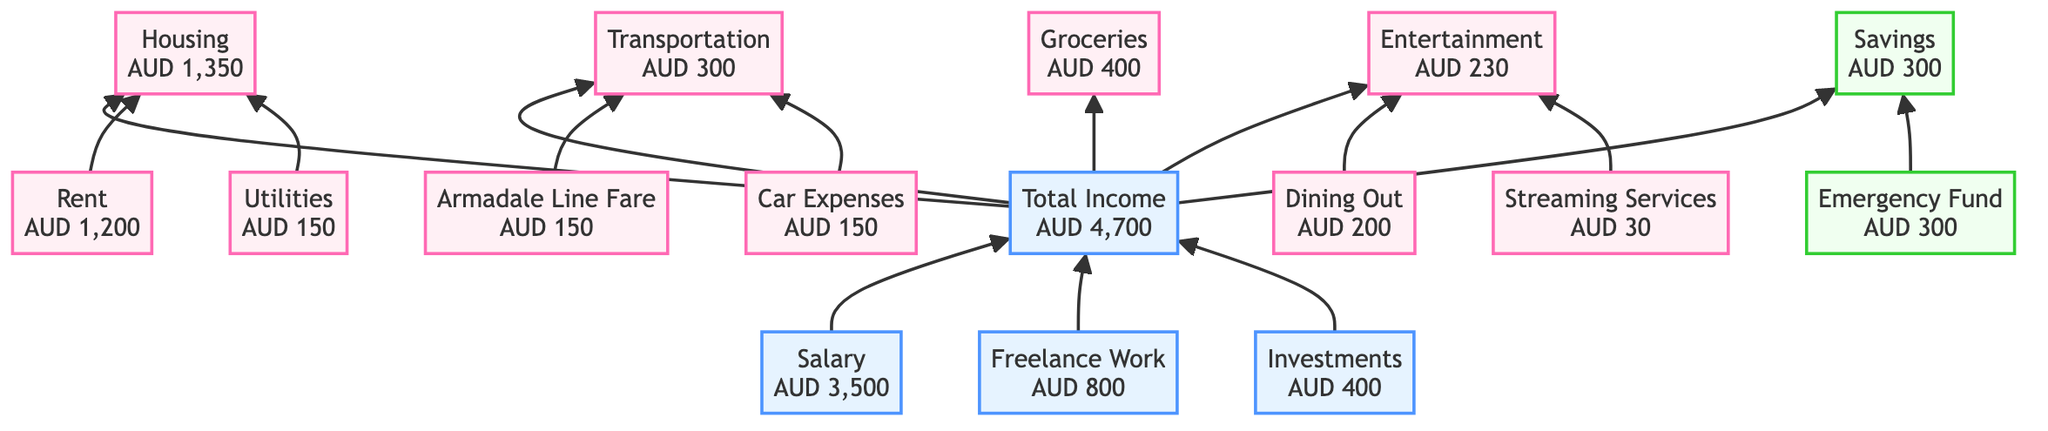What is the total income? The total income is derived from three sources: Salary (AUD 3,500), Freelance Work (AUD 800), and Investments (AUD 400). Adding them together results in 3,500 + 800 + 400, which equals AUD 4,700.
Answer: AUD 4,700 How much is allocated for housing expenses? Housing expenses are made up of Rent (AUD 1,200) and Utilities (AUD 150). Summing these amounts gives us 1,200 + 150, which equals AUD 1,350.
Answer: AUD 1,350 What is the monthly Armadale line fare? The Armadale line fare is indicated directly in the diagram as its own item, which shows the specific amount of AUD 150.
Answer: AUD 150 How much is spent on entertainment? The entertainment category includes Dining Out (AUD 200) and Streaming Services (AUD 30). By adding these two amounts together, we find that 200 + 30 equals AUD 230.
Answer: AUD 230 What is the single largest source of income? The largest source of income displayed in the diagram is Salary, which shows an amount of AUD 3,500, making it the highest among the income sources.
Answer: Salary What is the total amount spent on transportation? Transportation expenses include Armadale Line Fare (AUD 150) and Car Expenses (AUD 150). Car Expenses further break down into Fuel (AUD 100) and Maintenance (AUD 50), totaling 100 + 50 = AUD 150. Adding these gives 150 (Armadale) + 150 (Car) = AUD 300.
Answer: AUD 300 Which is the category that receives savings? The savings category is shown as "Savings" in the diagram, and contains a single item, Emergency Fund, which specifically indicates the monthly contribution of AUD 300.
Answer: Savings How many different expense categories are shown in the diagram? The diagram displays five expense categories: Housing, Transportation, Groceries, Entertainment, and Savings. So, by counting these categories, we find there are five in total.
Answer: 5 What is the relationship between salary and the total income? Salary is one of the three contributing components to total income, along with Freelance Work and Investments. The total income is the accumulation of all three sources, with Salary being the highest contributor to that total.
Answer: Contributing component 